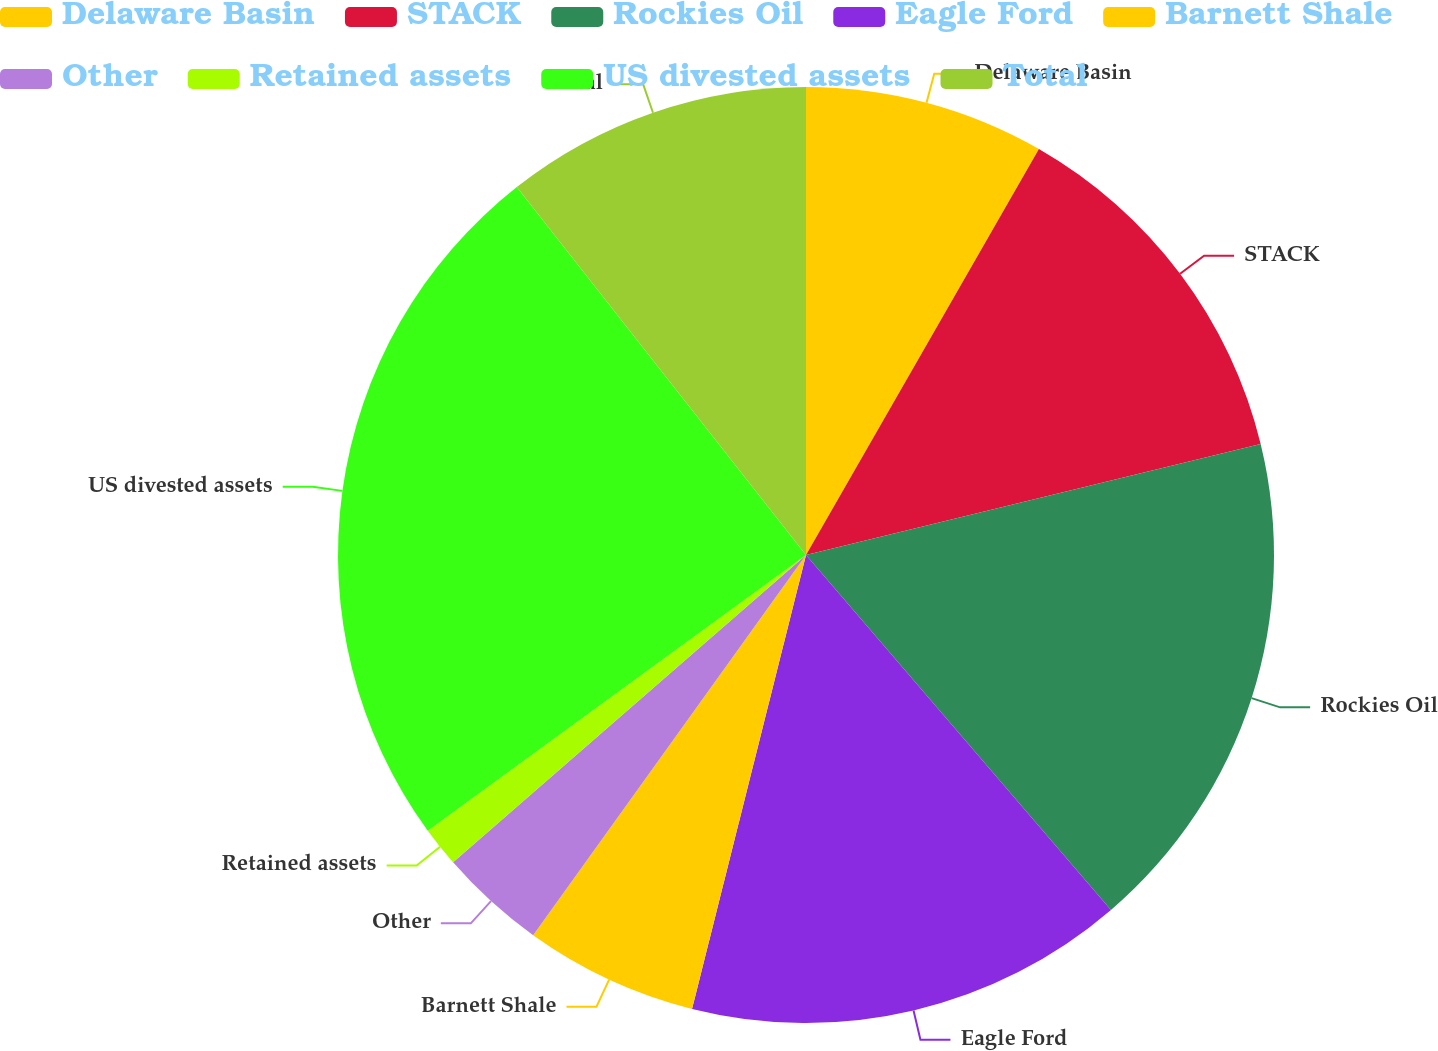<chart> <loc_0><loc_0><loc_500><loc_500><pie_chart><fcel>Delaware Basin<fcel>STACK<fcel>Rockies Oil<fcel>Eagle Ford<fcel>Barnett Shale<fcel>Other<fcel>Retained assets<fcel>US divested assets<fcel>Total<nl><fcel>8.29%<fcel>12.9%<fcel>17.51%<fcel>15.21%<fcel>5.99%<fcel>3.69%<fcel>1.38%<fcel>24.42%<fcel>10.6%<nl></chart> 